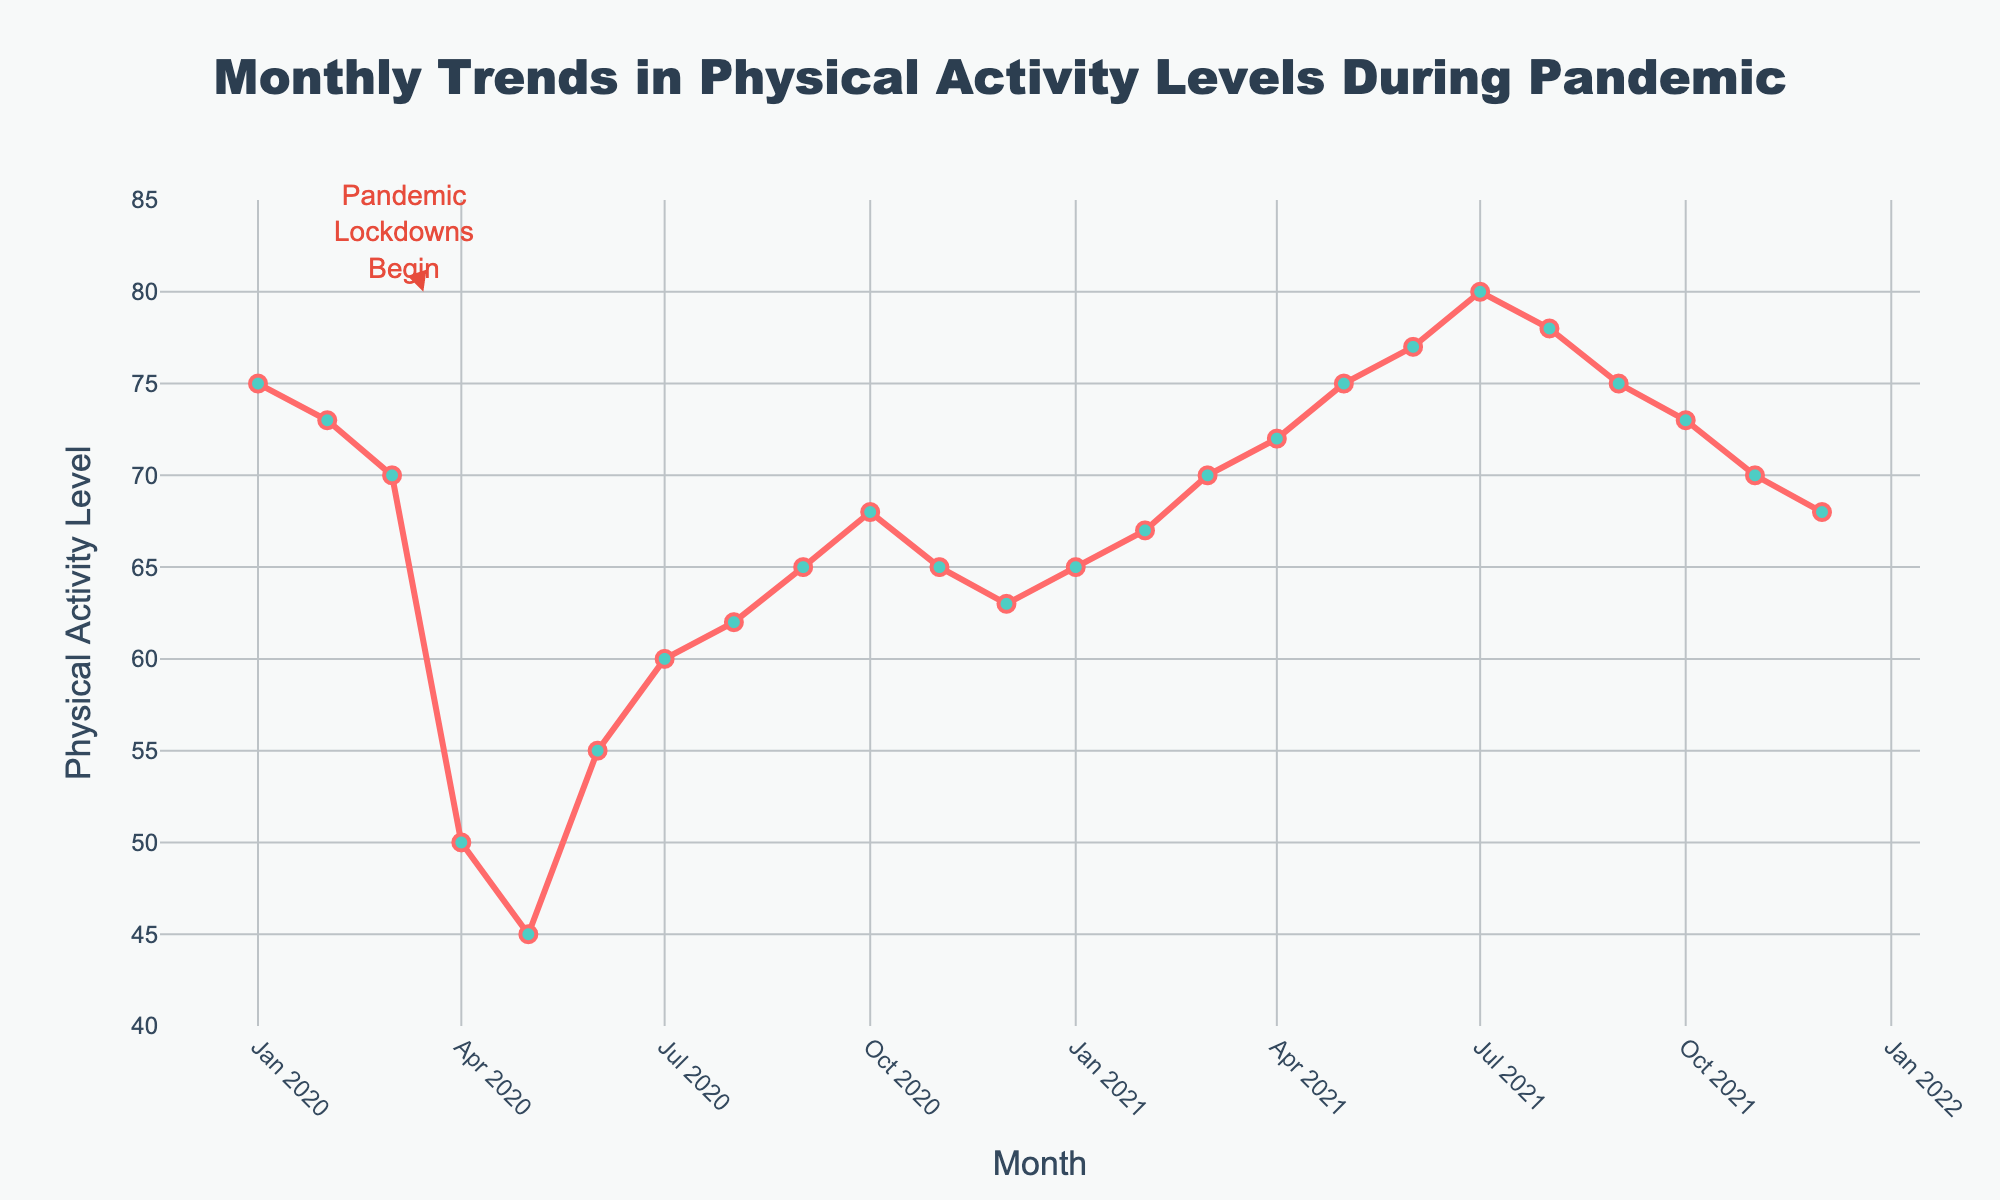When did the physical activity level see the lowest value? The lowest point on the y-axis corresponds to a physical activity level of 45, which occurs in May 2020 according to the x-axis.
Answer: May 2020 What was the physical activity level in January 2021? Refer to the x-axis for January 2021 and match it with the corresponding value on the y-axis, which is 65.
Answer: 65 How much did the physical activity level drop between February 2020 and April 2020? The physical activity level in February 2020 was 73, and in April 2020 it was 50. The drop is 73 - 50 = 23.
Answer: 23 Which month in 2021 had the highest physical activity level? Among the months in 2021, July had the highest physical activity level, which was 80, as seen on the y-axis.
Answer: July 2021 What trend can be observed in physical activity levels from April 2020 to July 2020? The physical activity level increased from 50 in April 2020 to 60 in July 2020, indicating an increasing trend over these months.
Answer: Increasing How did the physical activity level in September 2020 compare to that in September 2021? The physical activity level in September 2020 was 65, and in September 2021 it was 75. By comparing, we can see an increase from 65 to 75.
Answer: Increased By how much did the physical activity level change from the start of the pandemic lockdown in March 2020 to one year later in March 2021? The physical activity level in March 2020 was 70, and in March 2021 it was also 70. The change is 70 - 70 = 0.
Answer: 0 What is the overall trend in physical activity levels over the entire period? Initially, there was a sharp decline from January 2020 to May 2020, followed by a gradual recovery reaching peaks in mid-2021 and stabilizing towards the later months.
Answer: Decline followed by recovery and stabilization 